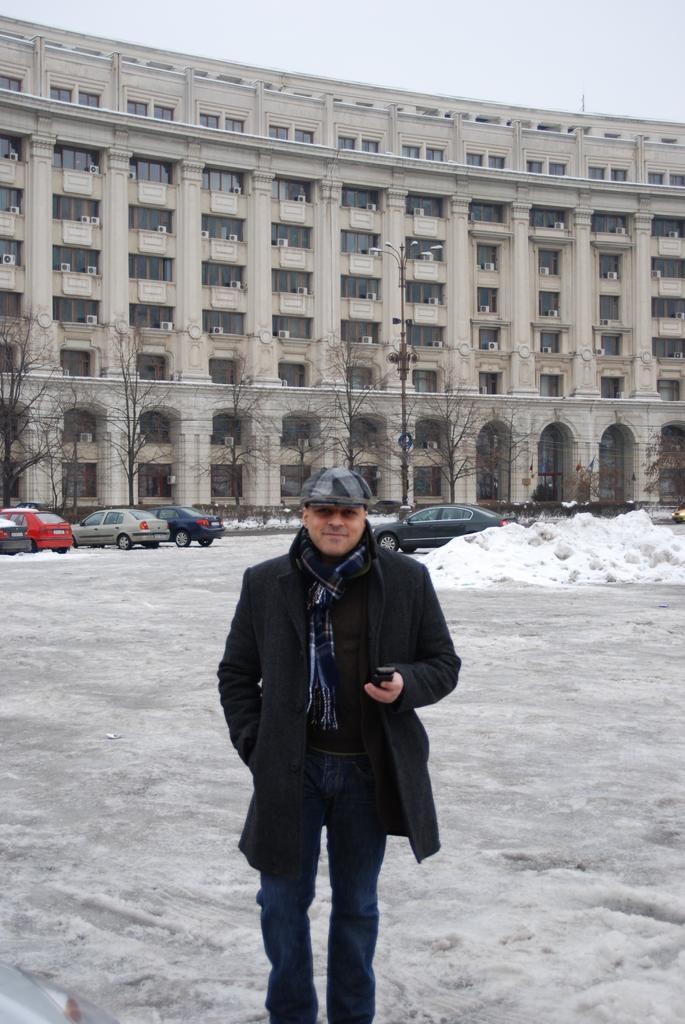How would you summarize this image in a sentence or two? In this image, we can see a man smiling and holding an object. In the background, we can see snow, trees, vehicles, building, walls, glass objects and the sky. 